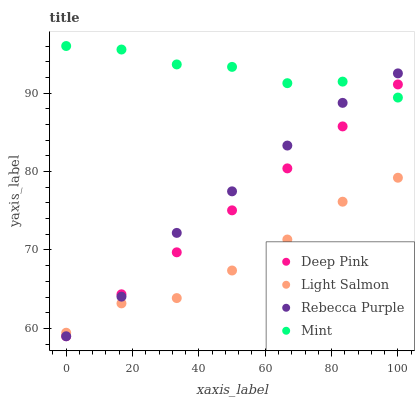Does Light Salmon have the minimum area under the curve?
Answer yes or no. Yes. Does Mint have the maximum area under the curve?
Answer yes or no. Yes. Does Deep Pink have the minimum area under the curve?
Answer yes or no. No. Does Deep Pink have the maximum area under the curve?
Answer yes or no. No. Is Deep Pink the smoothest?
Answer yes or no. Yes. Is Mint the roughest?
Answer yes or no. Yes. Is Mint the smoothest?
Answer yes or no. No. Is Deep Pink the roughest?
Answer yes or no. No. Does Deep Pink have the lowest value?
Answer yes or no. Yes. Does Mint have the lowest value?
Answer yes or no. No. Does Mint have the highest value?
Answer yes or no. Yes. Does Deep Pink have the highest value?
Answer yes or no. No. Is Light Salmon less than Mint?
Answer yes or no. Yes. Is Mint greater than Light Salmon?
Answer yes or no. Yes. Does Deep Pink intersect Rebecca Purple?
Answer yes or no. Yes. Is Deep Pink less than Rebecca Purple?
Answer yes or no. No. Is Deep Pink greater than Rebecca Purple?
Answer yes or no. No. Does Light Salmon intersect Mint?
Answer yes or no. No. 